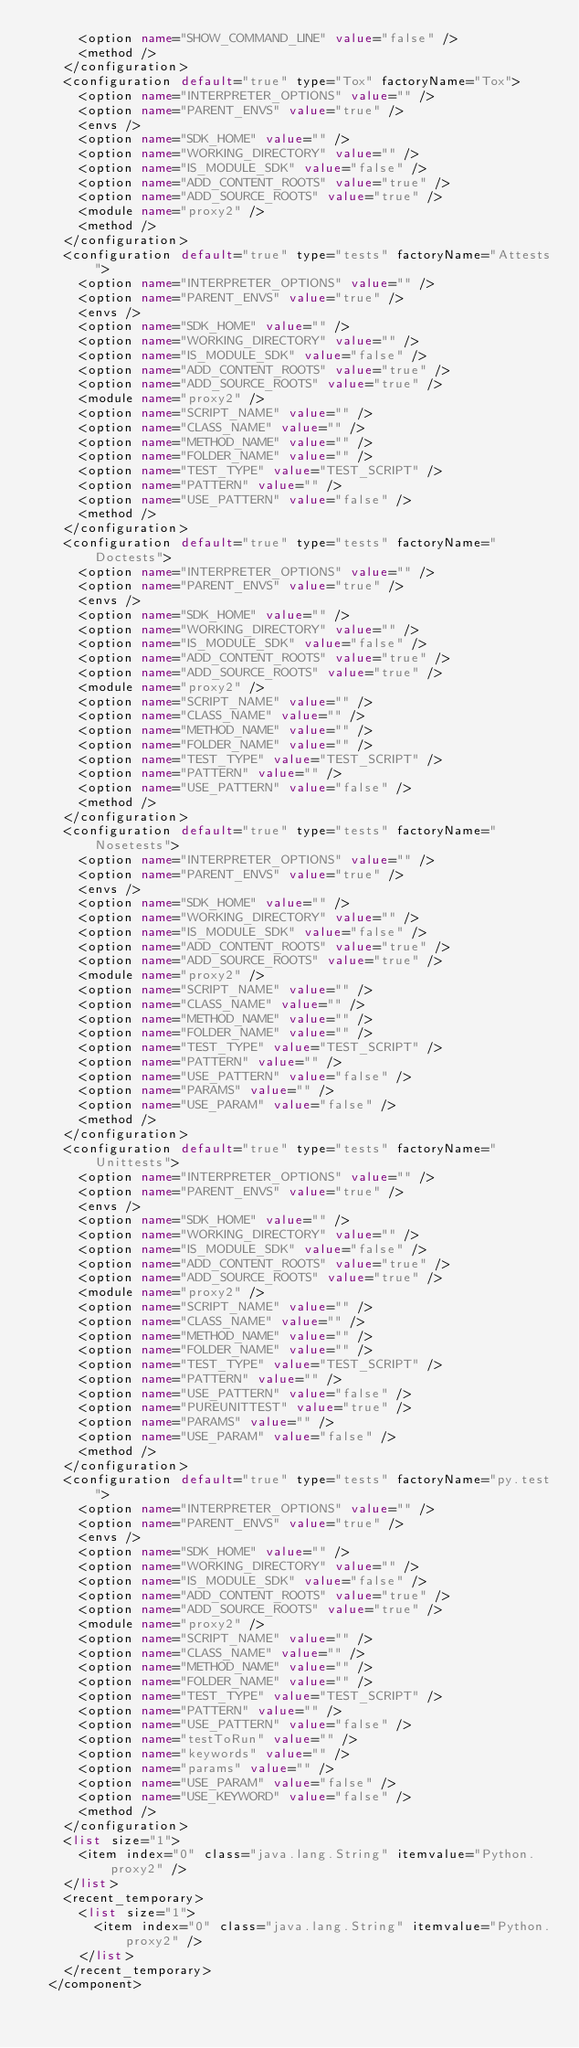<code> <loc_0><loc_0><loc_500><loc_500><_XML_>      <option name="SHOW_COMMAND_LINE" value="false" />
      <method />
    </configuration>
    <configuration default="true" type="Tox" factoryName="Tox">
      <option name="INTERPRETER_OPTIONS" value="" />
      <option name="PARENT_ENVS" value="true" />
      <envs />
      <option name="SDK_HOME" value="" />
      <option name="WORKING_DIRECTORY" value="" />
      <option name="IS_MODULE_SDK" value="false" />
      <option name="ADD_CONTENT_ROOTS" value="true" />
      <option name="ADD_SOURCE_ROOTS" value="true" />
      <module name="proxy2" />
      <method />
    </configuration>
    <configuration default="true" type="tests" factoryName="Attests">
      <option name="INTERPRETER_OPTIONS" value="" />
      <option name="PARENT_ENVS" value="true" />
      <envs />
      <option name="SDK_HOME" value="" />
      <option name="WORKING_DIRECTORY" value="" />
      <option name="IS_MODULE_SDK" value="false" />
      <option name="ADD_CONTENT_ROOTS" value="true" />
      <option name="ADD_SOURCE_ROOTS" value="true" />
      <module name="proxy2" />
      <option name="SCRIPT_NAME" value="" />
      <option name="CLASS_NAME" value="" />
      <option name="METHOD_NAME" value="" />
      <option name="FOLDER_NAME" value="" />
      <option name="TEST_TYPE" value="TEST_SCRIPT" />
      <option name="PATTERN" value="" />
      <option name="USE_PATTERN" value="false" />
      <method />
    </configuration>
    <configuration default="true" type="tests" factoryName="Doctests">
      <option name="INTERPRETER_OPTIONS" value="" />
      <option name="PARENT_ENVS" value="true" />
      <envs />
      <option name="SDK_HOME" value="" />
      <option name="WORKING_DIRECTORY" value="" />
      <option name="IS_MODULE_SDK" value="false" />
      <option name="ADD_CONTENT_ROOTS" value="true" />
      <option name="ADD_SOURCE_ROOTS" value="true" />
      <module name="proxy2" />
      <option name="SCRIPT_NAME" value="" />
      <option name="CLASS_NAME" value="" />
      <option name="METHOD_NAME" value="" />
      <option name="FOLDER_NAME" value="" />
      <option name="TEST_TYPE" value="TEST_SCRIPT" />
      <option name="PATTERN" value="" />
      <option name="USE_PATTERN" value="false" />
      <method />
    </configuration>
    <configuration default="true" type="tests" factoryName="Nosetests">
      <option name="INTERPRETER_OPTIONS" value="" />
      <option name="PARENT_ENVS" value="true" />
      <envs />
      <option name="SDK_HOME" value="" />
      <option name="WORKING_DIRECTORY" value="" />
      <option name="IS_MODULE_SDK" value="false" />
      <option name="ADD_CONTENT_ROOTS" value="true" />
      <option name="ADD_SOURCE_ROOTS" value="true" />
      <module name="proxy2" />
      <option name="SCRIPT_NAME" value="" />
      <option name="CLASS_NAME" value="" />
      <option name="METHOD_NAME" value="" />
      <option name="FOLDER_NAME" value="" />
      <option name="TEST_TYPE" value="TEST_SCRIPT" />
      <option name="PATTERN" value="" />
      <option name="USE_PATTERN" value="false" />
      <option name="PARAMS" value="" />
      <option name="USE_PARAM" value="false" />
      <method />
    </configuration>
    <configuration default="true" type="tests" factoryName="Unittests">
      <option name="INTERPRETER_OPTIONS" value="" />
      <option name="PARENT_ENVS" value="true" />
      <envs />
      <option name="SDK_HOME" value="" />
      <option name="WORKING_DIRECTORY" value="" />
      <option name="IS_MODULE_SDK" value="false" />
      <option name="ADD_CONTENT_ROOTS" value="true" />
      <option name="ADD_SOURCE_ROOTS" value="true" />
      <module name="proxy2" />
      <option name="SCRIPT_NAME" value="" />
      <option name="CLASS_NAME" value="" />
      <option name="METHOD_NAME" value="" />
      <option name="FOLDER_NAME" value="" />
      <option name="TEST_TYPE" value="TEST_SCRIPT" />
      <option name="PATTERN" value="" />
      <option name="USE_PATTERN" value="false" />
      <option name="PUREUNITTEST" value="true" />
      <option name="PARAMS" value="" />
      <option name="USE_PARAM" value="false" />
      <method />
    </configuration>
    <configuration default="true" type="tests" factoryName="py.test">
      <option name="INTERPRETER_OPTIONS" value="" />
      <option name="PARENT_ENVS" value="true" />
      <envs />
      <option name="SDK_HOME" value="" />
      <option name="WORKING_DIRECTORY" value="" />
      <option name="IS_MODULE_SDK" value="false" />
      <option name="ADD_CONTENT_ROOTS" value="true" />
      <option name="ADD_SOURCE_ROOTS" value="true" />
      <module name="proxy2" />
      <option name="SCRIPT_NAME" value="" />
      <option name="CLASS_NAME" value="" />
      <option name="METHOD_NAME" value="" />
      <option name="FOLDER_NAME" value="" />
      <option name="TEST_TYPE" value="TEST_SCRIPT" />
      <option name="PATTERN" value="" />
      <option name="USE_PATTERN" value="false" />
      <option name="testToRun" value="" />
      <option name="keywords" value="" />
      <option name="params" value="" />
      <option name="USE_PARAM" value="false" />
      <option name="USE_KEYWORD" value="false" />
      <method />
    </configuration>
    <list size="1">
      <item index="0" class="java.lang.String" itemvalue="Python.proxy2" />
    </list>
    <recent_temporary>
      <list size="1">
        <item index="0" class="java.lang.String" itemvalue="Python.proxy2" />
      </list>
    </recent_temporary>
  </component></code> 